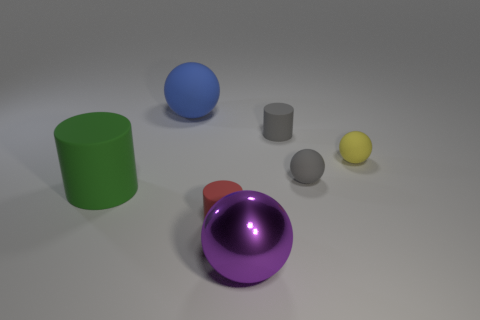Are there more small red things than tiny things? Upon reviewing the image, it appears that there is one small red object, which is the sphere, and when considering the term 'tiny' for relative size, there are three objects that could be categorized as such: the two small grey cylinders and the small yellow sphere. Therefore, there are fewer small red objects than tiny objects. 